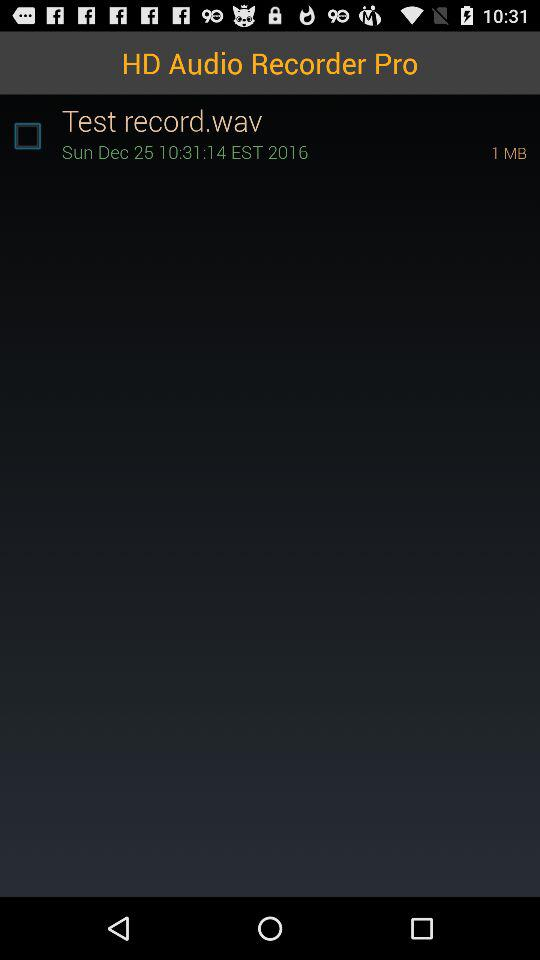How many MB of the file "Test Record.wav"? There is 1 MB of the file. 